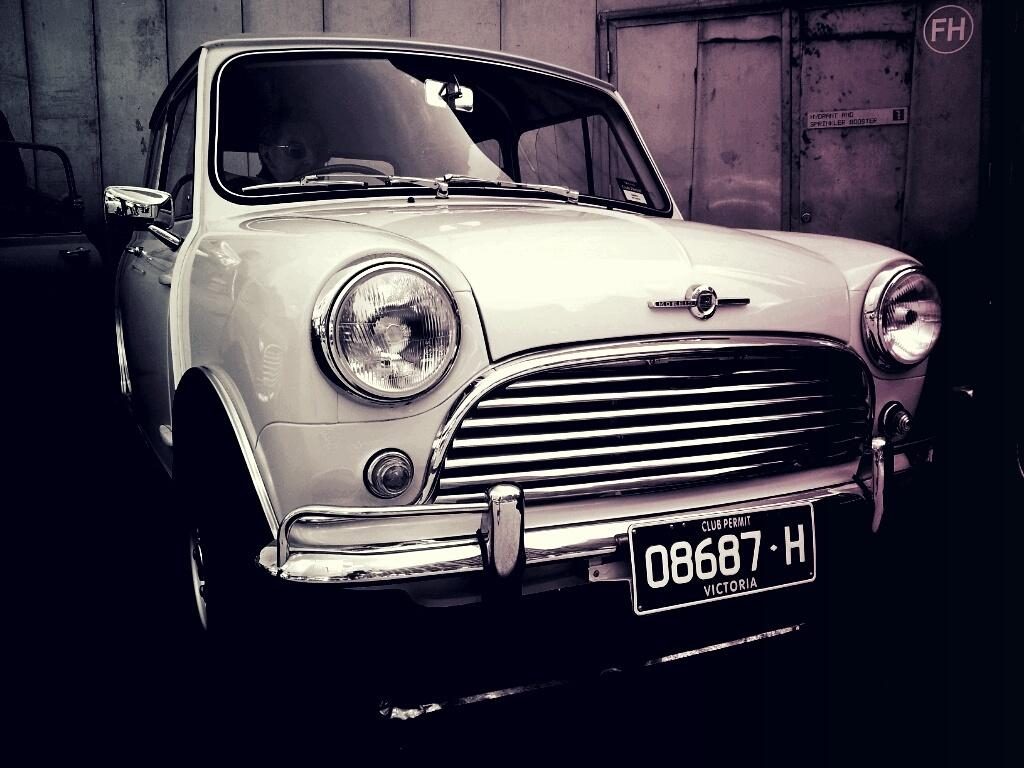<image>
Give a short and clear explanation of the subsequent image. A vintage car with the license plate 08687-H. 